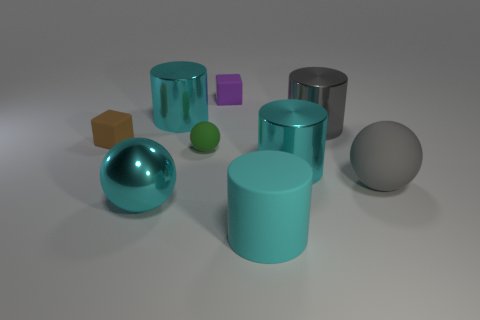Is the material of the cyan ball the same as the big ball on the right side of the purple cube?
Provide a succinct answer. No. There is a brown object that is the same shape as the small purple matte object; what is its size?
Provide a short and direct response. Small. What material is the purple cube?
Make the answer very short. Rubber. What material is the cyan object that is in front of the large cyan thing on the left side of the large cyan object that is behind the green rubber ball?
Keep it short and to the point. Rubber. There is a cylinder in front of the cyan metal sphere; does it have the same size as the ball that is behind the large matte sphere?
Offer a terse response. No. What number of other objects are the same material as the big gray ball?
Make the answer very short. 4. How many metallic things are tiny purple cubes or green objects?
Your answer should be compact. 0. Are there fewer big spheres than cyan shiny things?
Provide a short and direct response. Yes. Does the green thing have the same size as the matte thing that is in front of the metal sphere?
Your answer should be compact. No. Is there anything else that has the same shape as the tiny green matte thing?
Your answer should be compact. Yes. 